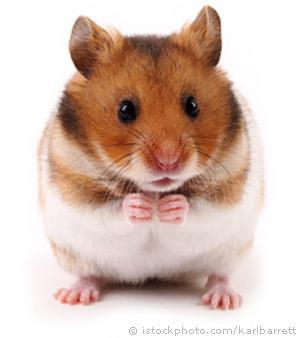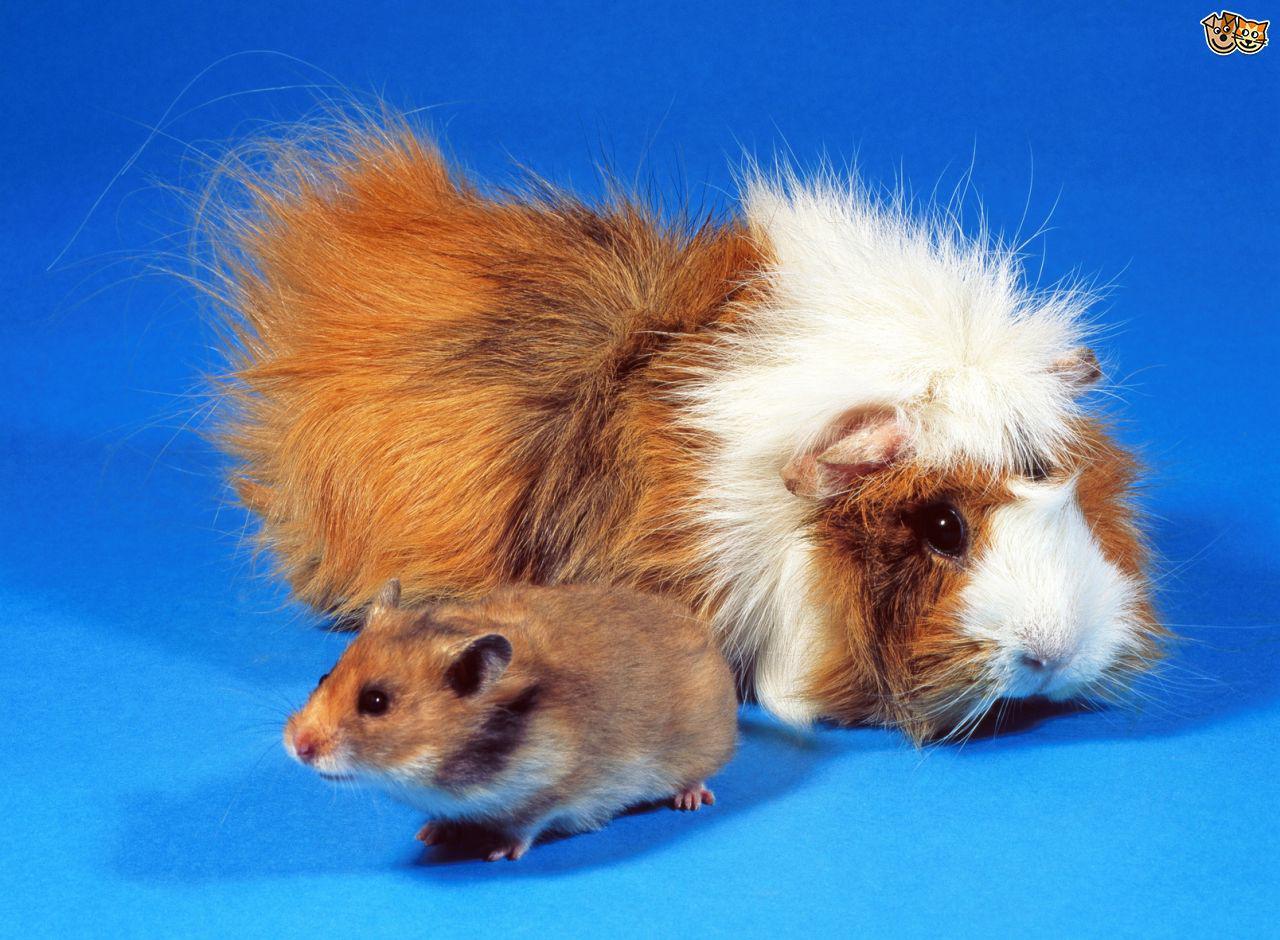The first image is the image on the left, the second image is the image on the right. Analyze the images presented: Is the assertion "A total of three rodent-type pets are shown." valid? Answer yes or no. Yes. 